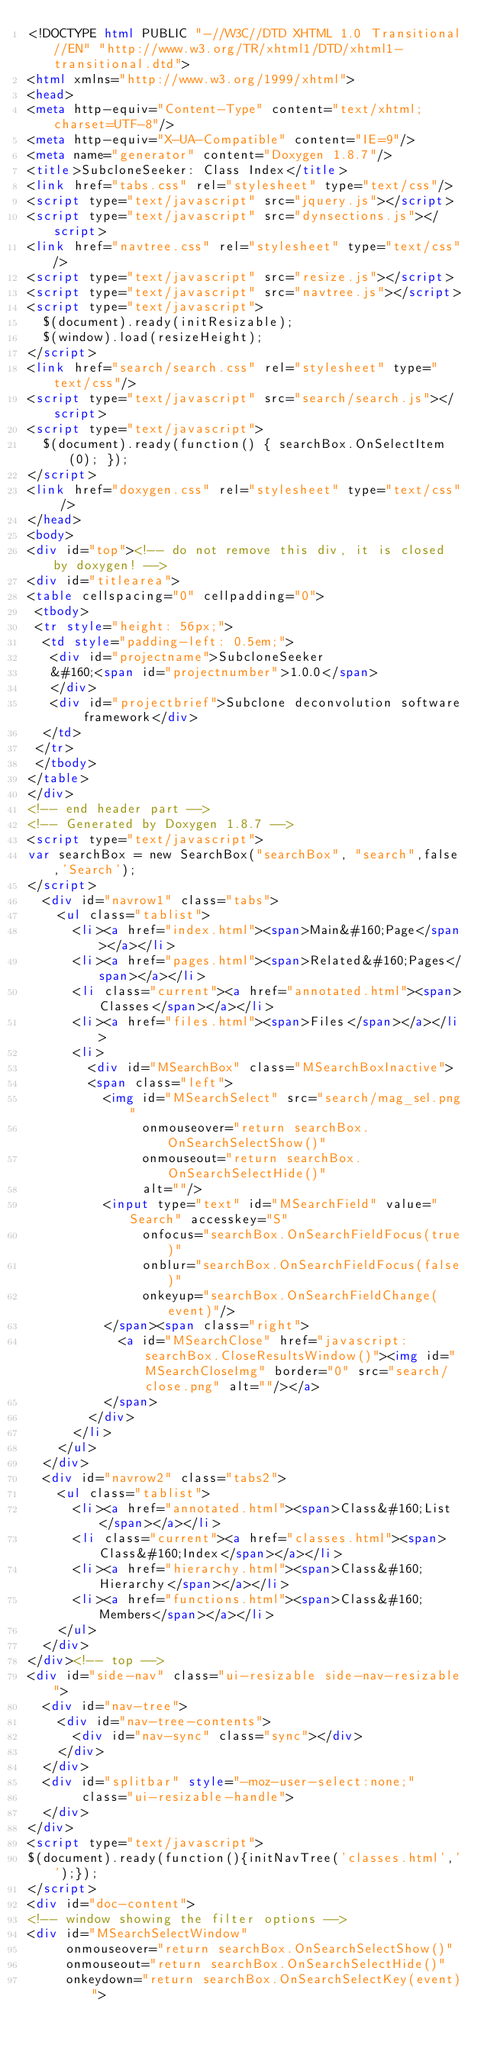<code> <loc_0><loc_0><loc_500><loc_500><_HTML_><!DOCTYPE html PUBLIC "-//W3C//DTD XHTML 1.0 Transitional//EN" "http://www.w3.org/TR/xhtml1/DTD/xhtml1-transitional.dtd">
<html xmlns="http://www.w3.org/1999/xhtml">
<head>
<meta http-equiv="Content-Type" content="text/xhtml;charset=UTF-8"/>
<meta http-equiv="X-UA-Compatible" content="IE=9"/>
<meta name="generator" content="Doxygen 1.8.7"/>
<title>SubcloneSeeker: Class Index</title>
<link href="tabs.css" rel="stylesheet" type="text/css"/>
<script type="text/javascript" src="jquery.js"></script>
<script type="text/javascript" src="dynsections.js"></script>
<link href="navtree.css" rel="stylesheet" type="text/css"/>
<script type="text/javascript" src="resize.js"></script>
<script type="text/javascript" src="navtree.js"></script>
<script type="text/javascript">
  $(document).ready(initResizable);
  $(window).load(resizeHeight);
</script>
<link href="search/search.css" rel="stylesheet" type="text/css"/>
<script type="text/javascript" src="search/search.js"></script>
<script type="text/javascript">
  $(document).ready(function() { searchBox.OnSelectItem(0); });
</script>
<link href="doxygen.css" rel="stylesheet" type="text/css" />
</head>
<body>
<div id="top"><!-- do not remove this div, it is closed by doxygen! -->
<div id="titlearea">
<table cellspacing="0" cellpadding="0">
 <tbody>
 <tr style="height: 56px;">
  <td style="padding-left: 0.5em;">
   <div id="projectname">SubcloneSeeker
   &#160;<span id="projectnumber">1.0.0</span>
   </div>
   <div id="projectbrief">Subclone deconvolution software framework</div>
  </td>
 </tr>
 </tbody>
</table>
</div>
<!-- end header part -->
<!-- Generated by Doxygen 1.8.7 -->
<script type="text/javascript">
var searchBox = new SearchBox("searchBox", "search",false,'Search');
</script>
  <div id="navrow1" class="tabs">
    <ul class="tablist">
      <li><a href="index.html"><span>Main&#160;Page</span></a></li>
      <li><a href="pages.html"><span>Related&#160;Pages</span></a></li>
      <li class="current"><a href="annotated.html"><span>Classes</span></a></li>
      <li><a href="files.html"><span>Files</span></a></li>
      <li>
        <div id="MSearchBox" class="MSearchBoxInactive">
        <span class="left">
          <img id="MSearchSelect" src="search/mag_sel.png"
               onmouseover="return searchBox.OnSearchSelectShow()"
               onmouseout="return searchBox.OnSearchSelectHide()"
               alt=""/>
          <input type="text" id="MSearchField" value="Search" accesskey="S"
               onfocus="searchBox.OnSearchFieldFocus(true)" 
               onblur="searchBox.OnSearchFieldFocus(false)" 
               onkeyup="searchBox.OnSearchFieldChange(event)"/>
          </span><span class="right">
            <a id="MSearchClose" href="javascript:searchBox.CloseResultsWindow()"><img id="MSearchCloseImg" border="0" src="search/close.png" alt=""/></a>
          </span>
        </div>
      </li>
    </ul>
  </div>
  <div id="navrow2" class="tabs2">
    <ul class="tablist">
      <li><a href="annotated.html"><span>Class&#160;List</span></a></li>
      <li class="current"><a href="classes.html"><span>Class&#160;Index</span></a></li>
      <li><a href="hierarchy.html"><span>Class&#160;Hierarchy</span></a></li>
      <li><a href="functions.html"><span>Class&#160;Members</span></a></li>
    </ul>
  </div>
</div><!-- top -->
<div id="side-nav" class="ui-resizable side-nav-resizable">
  <div id="nav-tree">
    <div id="nav-tree-contents">
      <div id="nav-sync" class="sync"></div>
    </div>
  </div>
  <div id="splitbar" style="-moz-user-select:none;" 
       class="ui-resizable-handle">
  </div>
</div>
<script type="text/javascript">
$(document).ready(function(){initNavTree('classes.html','');});
</script>
<div id="doc-content">
<!-- window showing the filter options -->
<div id="MSearchSelectWindow"
     onmouseover="return searchBox.OnSearchSelectShow()"
     onmouseout="return searchBox.OnSearchSelectHide()"
     onkeydown="return searchBox.OnSearchSelectKey(event)"></code> 